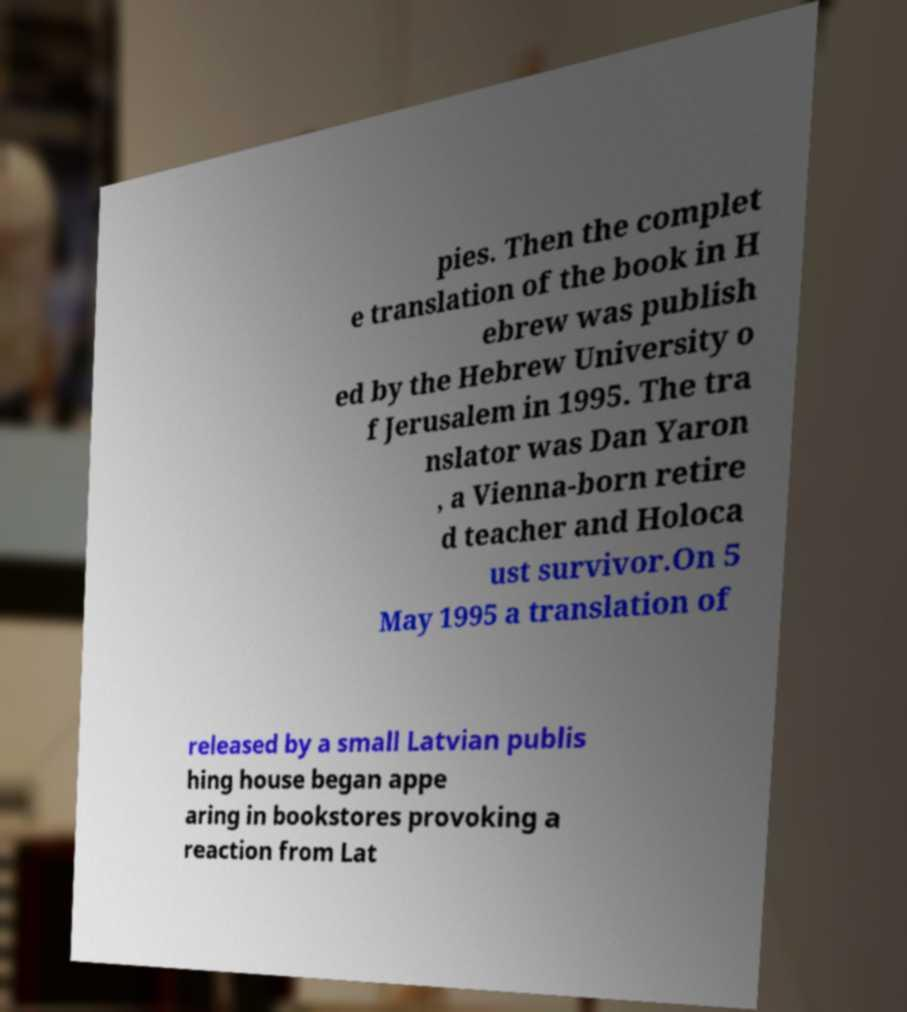Please identify and transcribe the text found in this image. pies. Then the complet e translation of the book in H ebrew was publish ed by the Hebrew University o f Jerusalem in 1995. The tra nslator was Dan Yaron , a Vienna-born retire d teacher and Holoca ust survivor.On 5 May 1995 a translation of released by a small Latvian publis hing house began appe aring in bookstores provoking a reaction from Lat 